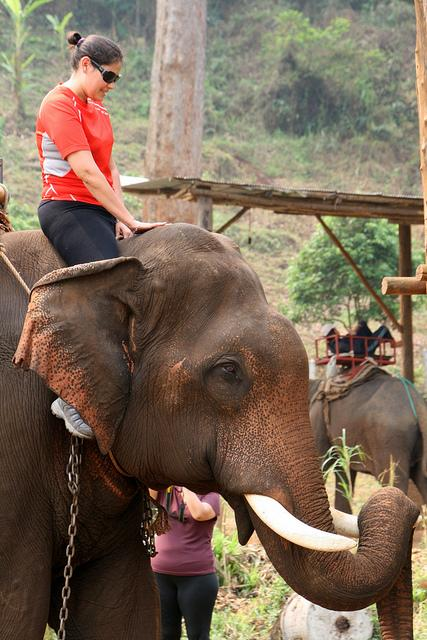Why is there a chain on the elephant? it's property 